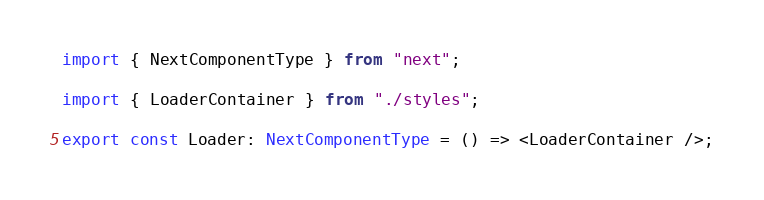Convert code to text. <code><loc_0><loc_0><loc_500><loc_500><_TypeScript_>import { NextComponentType } from "next";

import { LoaderContainer } from "./styles";

export const Loader: NextComponentType = () => <LoaderContainer />;
</code> 